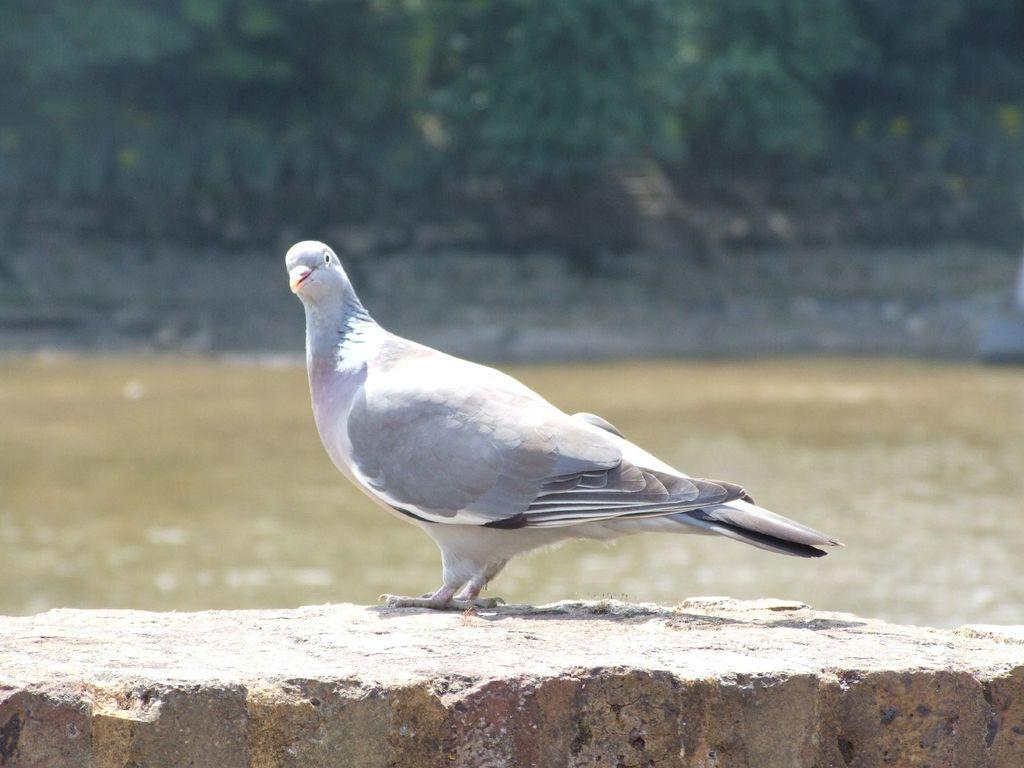Describe this image in one or two sentences. In the picture we can see a pigeon which is gray in color standing on the wall and behind it we can see water and some plants which are not clearly visible. 